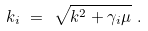<formula> <loc_0><loc_0><loc_500><loc_500>k _ { i } \ = \ \sqrt { k ^ { 2 } + \gamma _ { i } \mu } \ .</formula> 